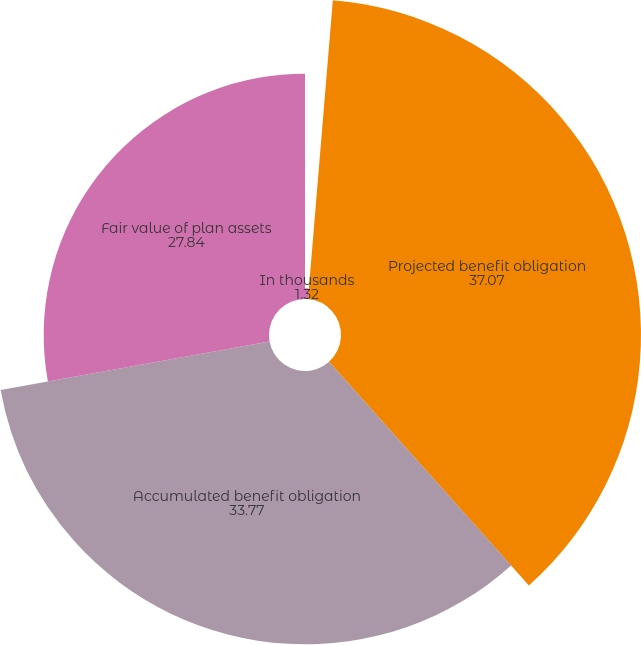Convert chart to OTSL. <chart><loc_0><loc_0><loc_500><loc_500><pie_chart><fcel>In thousands<fcel>Projected benefit obligation<fcel>Accumulated benefit obligation<fcel>Fair value of plan assets<nl><fcel>1.32%<fcel>37.07%<fcel>33.77%<fcel>27.84%<nl></chart> 